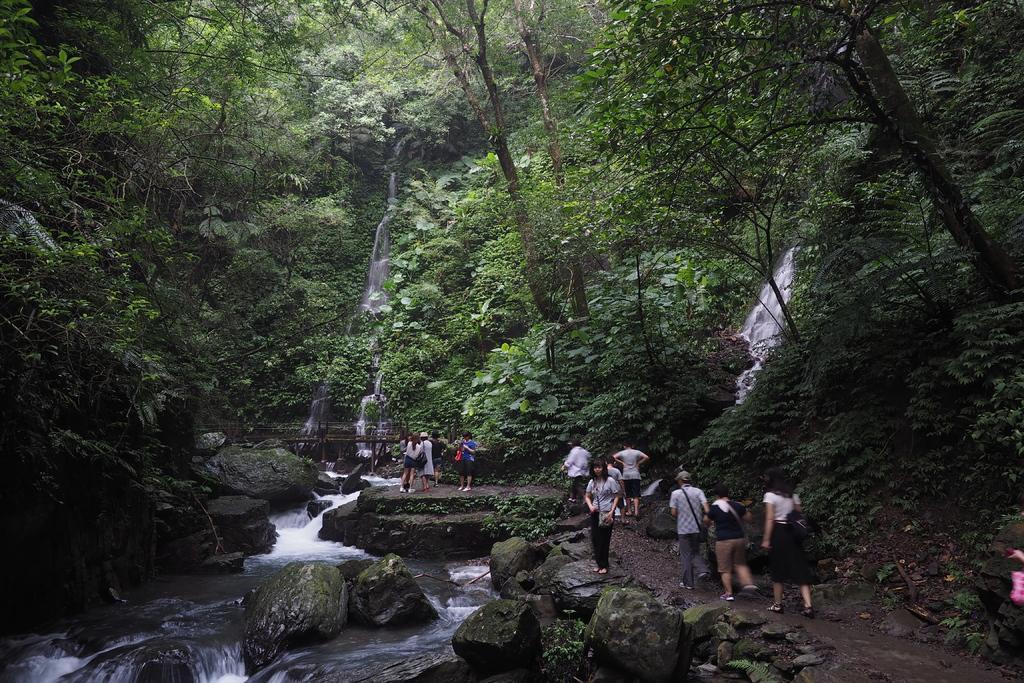Please provide a concise description of this image. In this picture i can see a group of people are standing. On the left side i can see water and rocks. In the background i can see trees. 